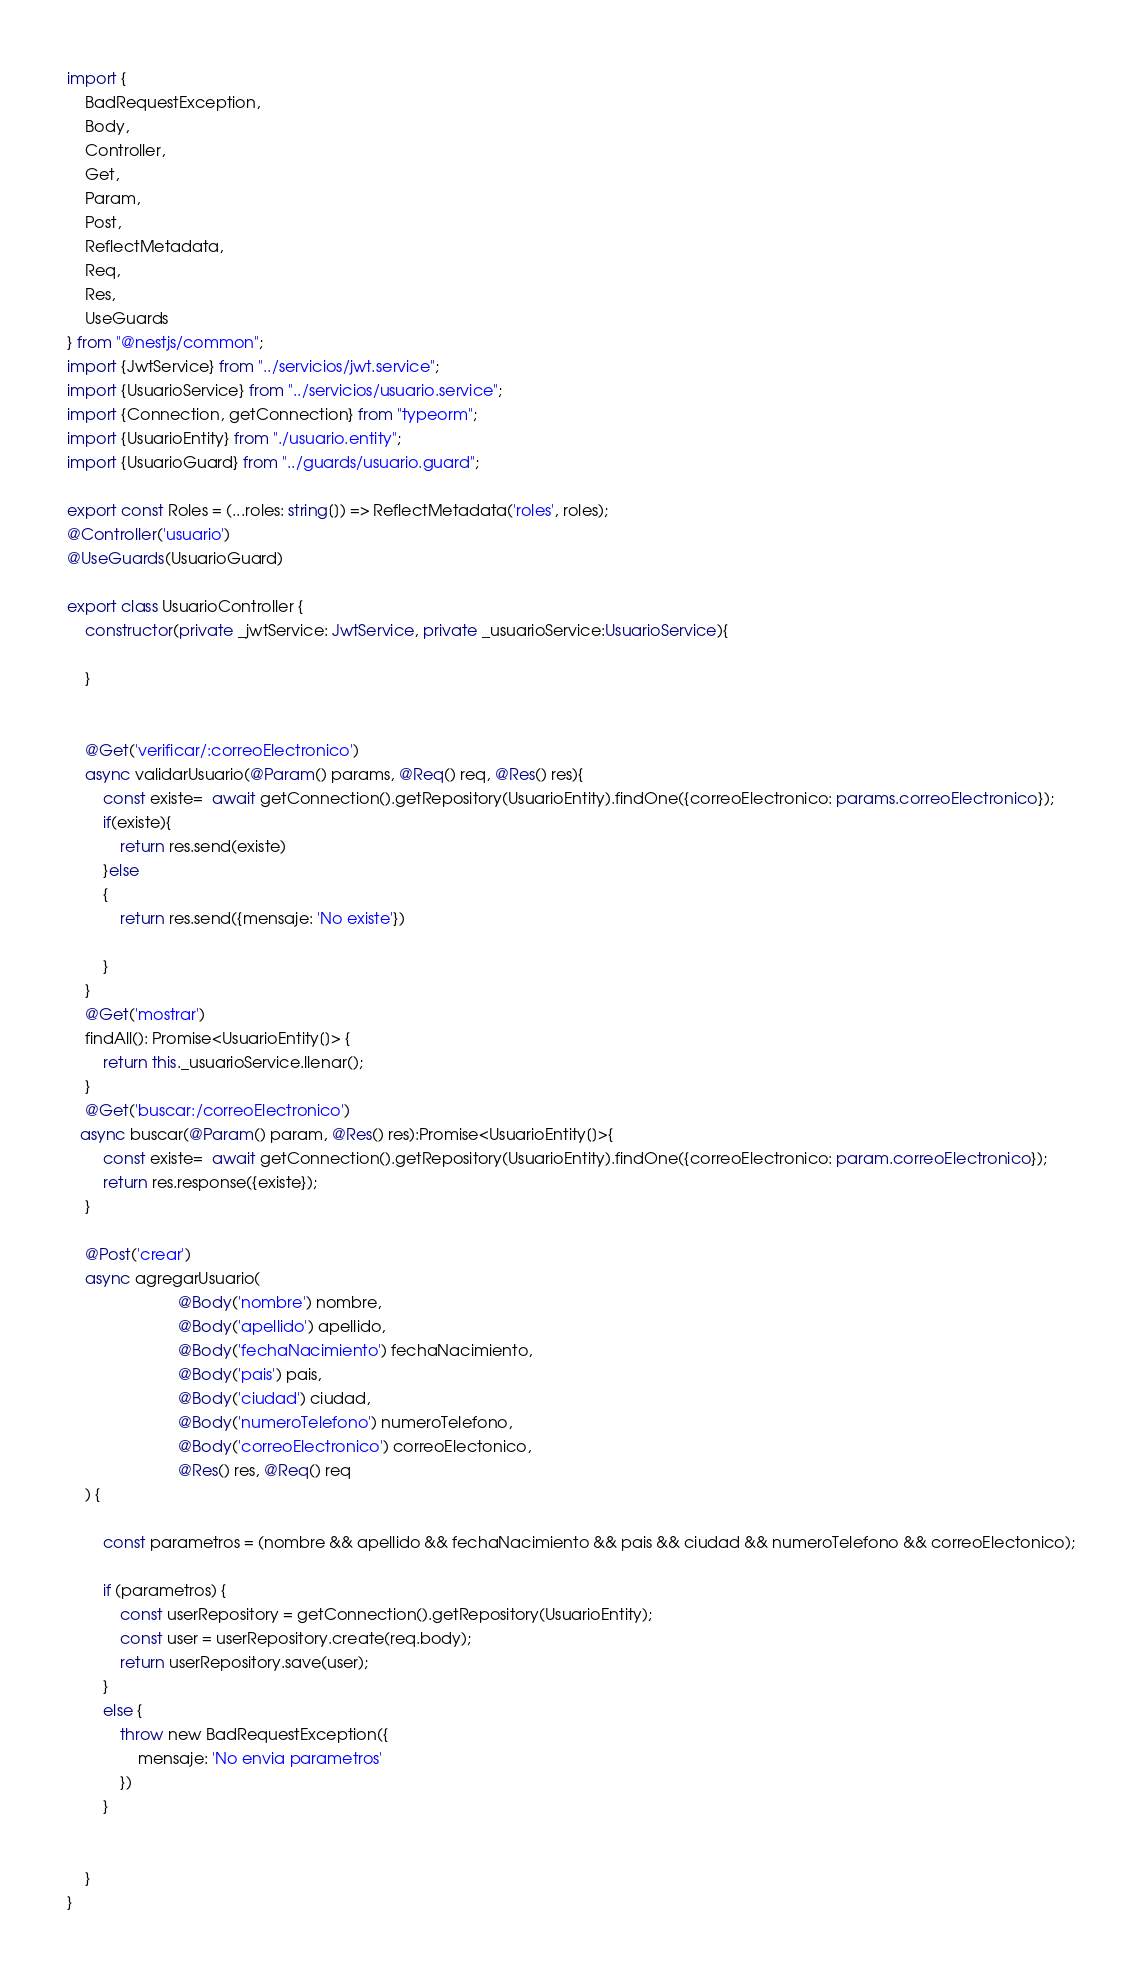Convert code to text. <code><loc_0><loc_0><loc_500><loc_500><_TypeScript_>import {
    BadRequestException,
    Body,
    Controller,
    Get,
    Param,
    Post,
    ReflectMetadata,
    Req,
    Res,
    UseGuards
} from "@nestjs/common";
import {JwtService} from "../servicios/jwt.service";
import {UsuarioService} from "../servicios/usuario.service";
import {Connection, getConnection} from "typeorm";
import {UsuarioEntity} from "./usuario.entity";
import {UsuarioGuard} from "../guards/usuario.guard";

export const Roles = (...roles: string[]) => ReflectMetadata('roles', roles);
@Controller('usuario')
@UseGuards(UsuarioGuard)

export class UsuarioController {
    constructor(private _jwtService: JwtService, private _usuarioService:UsuarioService){

    }


    @Get('verificar/:correoElectronico')
    async validarUsuario(@Param() params, @Req() req, @Res() res){
        const existe=  await getConnection().getRepository(UsuarioEntity).findOne({correoElectronico: params.correoElectronico});
        if(existe){
            return res.send(existe)
        }else
        {
            return res.send({mensaje: 'No existe'})

        }
    }
    @Get('mostrar')
    findAll(): Promise<UsuarioEntity[]> {
        return this._usuarioService.llenar();
    }
    @Get('buscar:/correoElectronico')
   async buscar(@Param() param, @Res() res):Promise<UsuarioEntity[]>{
        const existe=  await getConnection().getRepository(UsuarioEntity).findOne({correoElectronico: param.correoElectronico});
        return res.response({existe});
    }

    @Post('crear')
    async agregarUsuario(
                         @Body('nombre') nombre,
                         @Body('apellido') apellido,
                         @Body('fechaNacimiento') fechaNacimiento,
                         @Body('pais') pais,
                         @Body('ciudad') ciudad,
                         @Body('numeroTelefono') numeroTelefono,
                         @Body('correoElectronico') correoElectonico,
                         @Res() res, @Req() req
    ) {

        const parametros = (nombre && apellido && fechaNacimiento && pais && ciudad && numeroTelefono && correoElectonico);

        if (parametros) {
            const userRepository = getConnection().getRepository(UsuarioEntity);
            const user = userRepository.create(req.body);
            return userRepository.save(user);
        }
        else {
            throw new BadRequestException({
                mensaje: 'No envia parametros'
            })
        }


    }
}</code> 